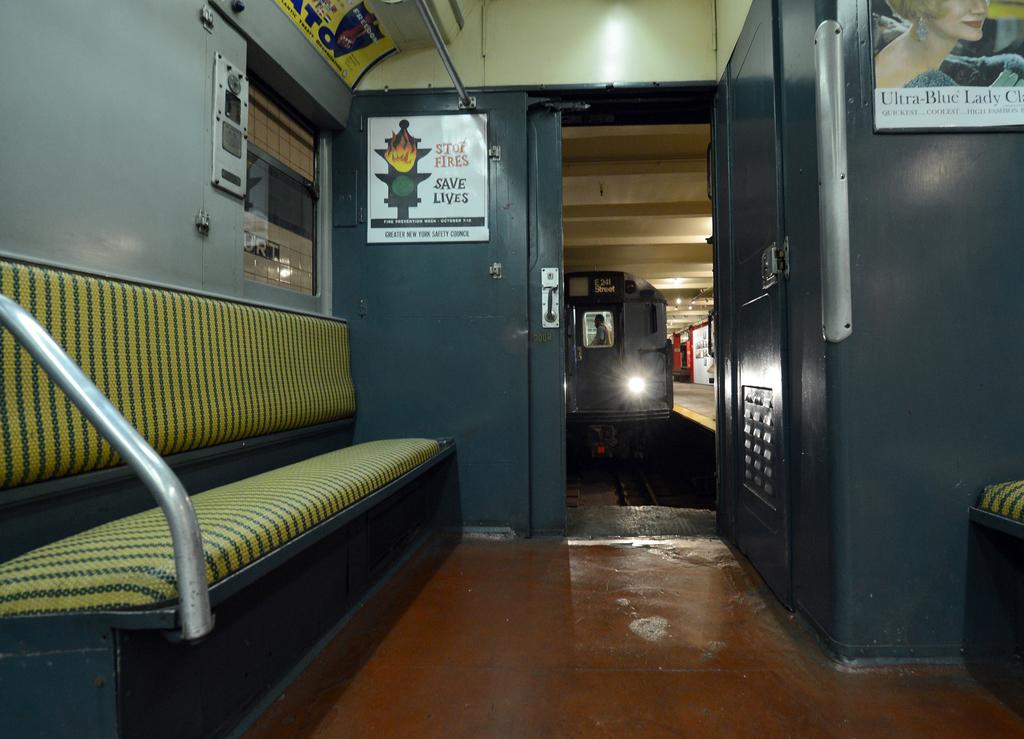What save lives?
Keep it short and to the point. Stop fires. 